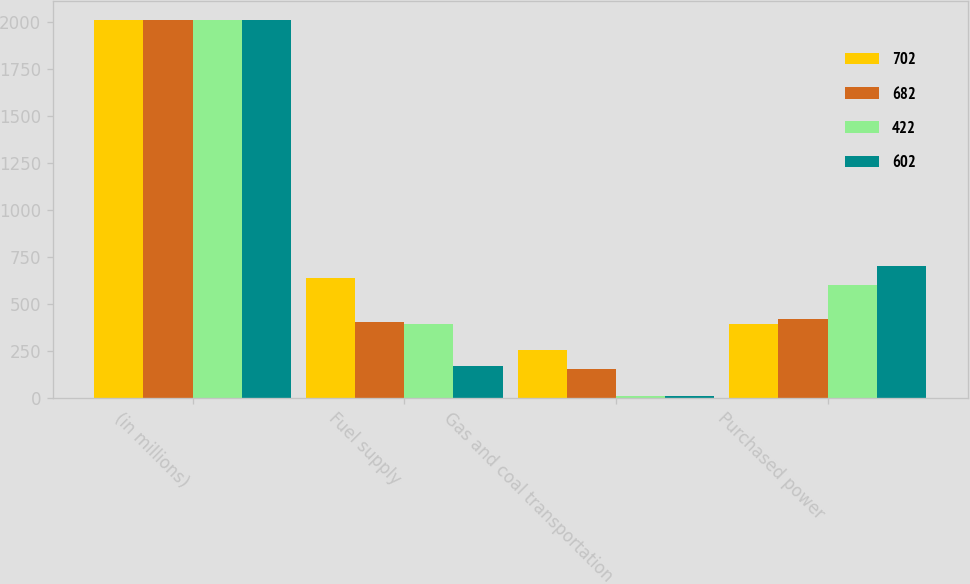<chart> <loc_0><loc_0><loc_500><loc_500><stacked_bar_chart><ecel><fcel>(in millions)<fcel>Fuel supply<fcel>Gas and coal transportation<fcel>Purchased power<nl><fcel>702<fcel>2010<fcel>637<fcel>252<fcel>395<nl><fcel>682<fcel>2011<fcel>405<fcel>152<fcel>422<nl><fcel>422<fcel>2012<fcel>392<fcel>8<fcel>602<nl><fcel>602<fcel>2013<fcel>172<fcel>9<fcel>702<nl></chart> 